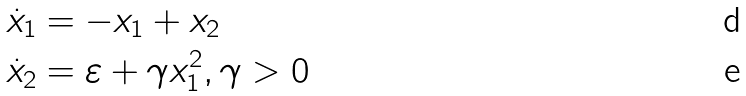<formula> <loc_0><loc_0><loc_500><loc_500>\dot { x } _ { 1 } & = - x _ { 1 } + x _ { 2 } \\ \dot { x } _ { 2 } & = \varepsilon + \gamma x _ { 1 } ^ { 2 } , \gamma > 0</formula> 